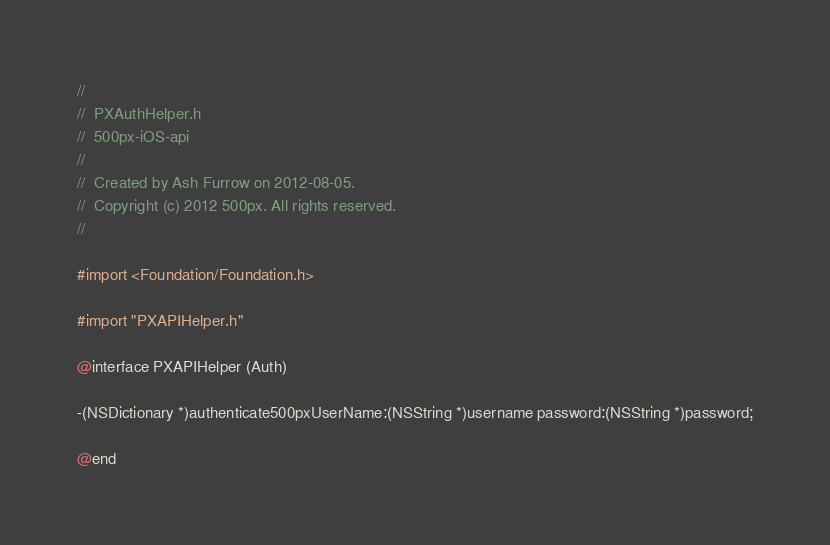Convert code to text. <code><loc_0><loc_0><loc_500><loc_500><_C_>//
//  PXAuthHelper.h
//  500px-iOS-api
//
//  Created by Ash Furrow on 2012-08-05.
//  Copyright (c) 2012 500px. All rights reserved.
//

#import <Foundation/Foundation.h>

#import "PXAPIHelper.h"

@interface PXAPIHelper (Auth)

-(NSDictionary *)authenticate500pxUserName:(NSString *)username password:(NSString *)password;

@end
</code> 